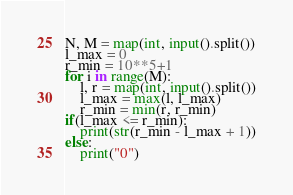Convert code to text. <code><loc_0><loc_0><loc_500><loc_500><_Python_>N, M = map(int, input().split())
l_max = 0
r_min = 10**5+1
for i in range(M):
	l, r = map(int, input().split())
	l_max = max(l, l_max)
	r_min = min(r, r_min)
if(l_max <= r_min):
	print(str(r_min - l_max + 1))
else:
	print("0")</code> 